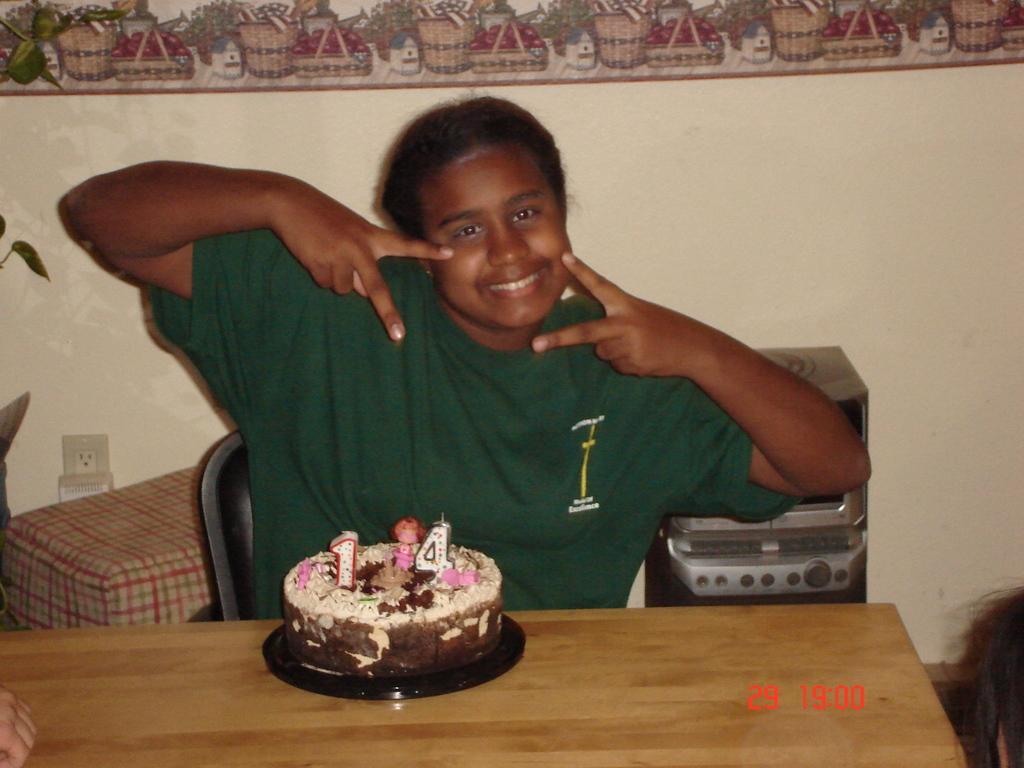How would you summarize this image in a sentence or two? This is the picture of a person wearing green shirt sitting on the chair in front of the table on which there is a cake and behind her there is a desk and a speaker. 